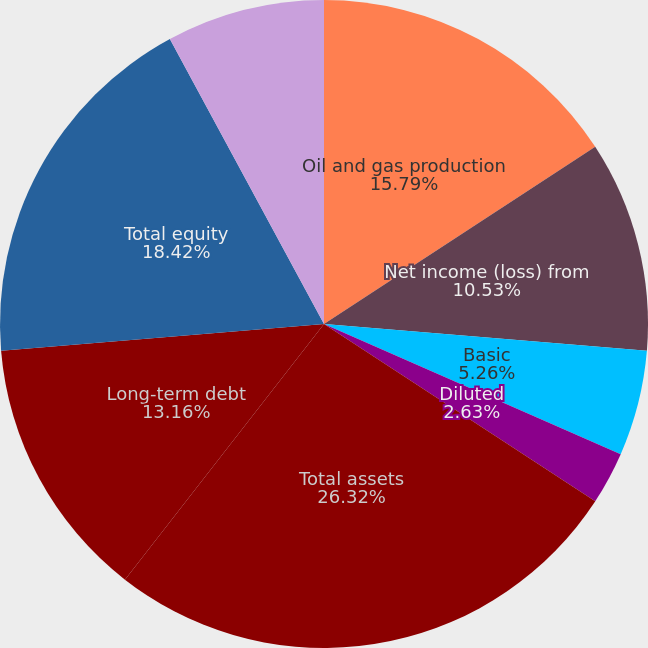<chart> <loc_0><loc_0><loc_500><loc_500><pie_chart><fcel>Oil and gas production<fcel>Net income (loss) from<fcel>Basic<fcel>Diluted<fcel>Cash dividends declared per<fcel>Total assets<fcel>Long-term debt<fcel>Total equity<fcel>Common shares outstanding<nl><fcel>15.79%<fcel>10.53%<fcel>5.26%<fcel>2.63%<fcel>0.0%<fcel>26.32%<fcel>13.16%<fcel>18.42%<fcel>7.89%<nl></chart> 